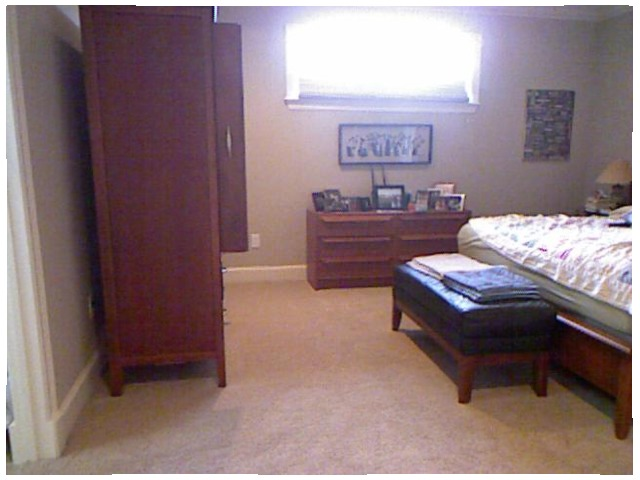<image>
Is the photo frame under the window? Yes. The photo frame is positioned underneath the window, with the window above it in the vertical space. Is there a towel on the bench? Yes. Looking at the image, I can see the towel is positioned on top of the bench, with the bench providing support. Where is the wall in relation to the cupboard? Is it to the right of the cupboard? No. The wall is not to the right of the cupboard. The horizontal positioning shows a different relationship. 